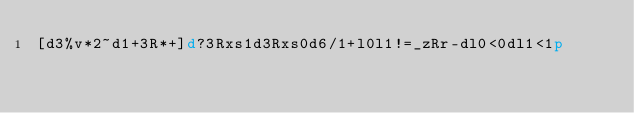<code> <loc_0><loc_0><loc_500><loc_500><_dc_>[d3%v*2~d1+3R*+]d?3Rxs1d3Rxs0d6/1+l0l1!=_zRr-dl0<0dl1<1p</code> 